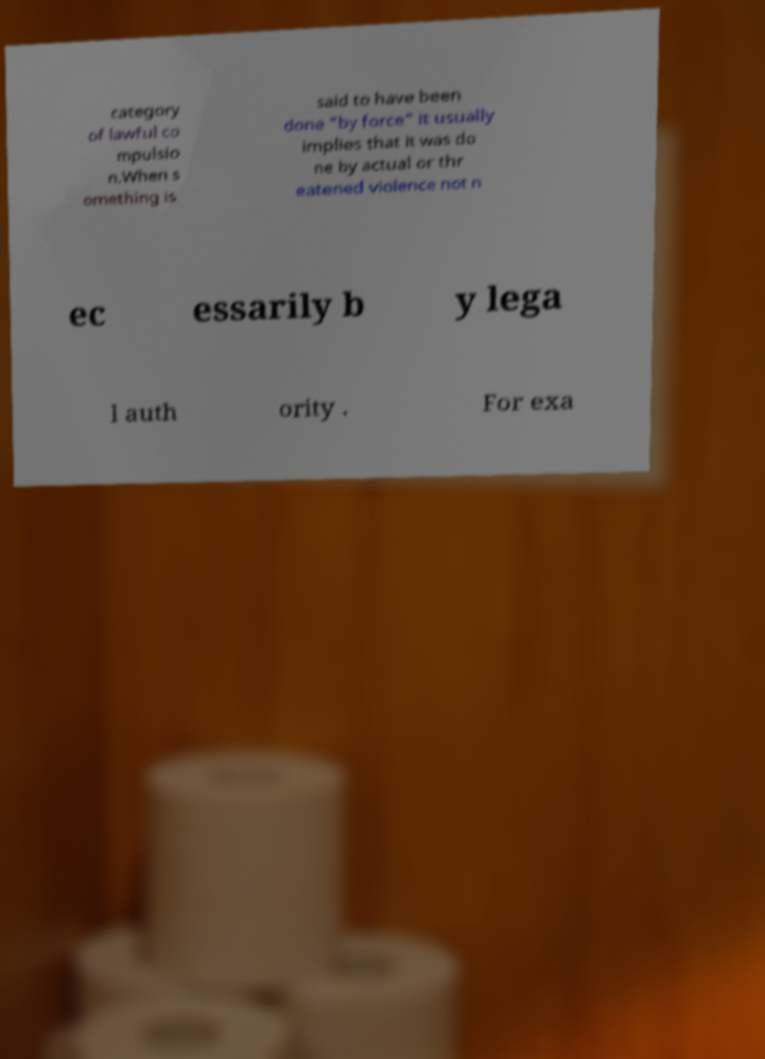Can you read and provide the text displayed in the image?This photo seems to have some interesting text. Can you extract and type it out for me? category of lawful co mpulsio n.When s omething is said to have been done "by force" it usually implies that it was do ne by actual or thr eatened violence not n ec essarily b y lega l auth ority . For exa 